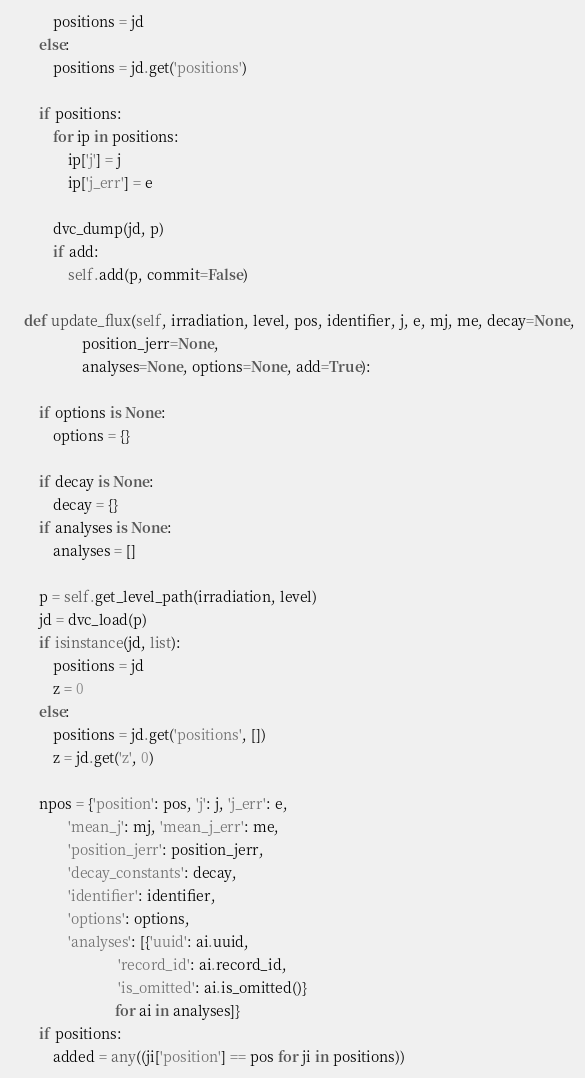Convert code to text. <code><loc_0><loc_0><loc_500><loc_500><_Python_>            positions = jd
        else:
            positions = jd.get('positions')

        if positions:
            for ip in positions:
                ip['j'] = j
                ip['j_err'] = e

            dvc_dump(jd, p)
            if add:
                self.add(p, commit=False)

    def update_flux(self, irradiation, level, pos, identifier, j, e, mj, me, decay=None,
                    position_jerr=None,
                    analyses=None, options=None, add=True):

        if options is None:
            options = {}

        if decay is None:
            decay = {}
        if analyses is None:
            analyses = []

        p = self.get_level_path(irradiation, level)
        jd = dvc_load(p)
        if isinstance(jd, list):
            positions = jd
            z = 0
        else:
            positions = jd.get('positions', [])
            z = jd.get('z', 0)

        npos = {'position': pos, 'j': j, 'j_err': e,
                'mean_j': mj, 'mean_j_err': me,
                'position_jerr': position_jerr,
                'decay_constants': decay,
                'identifier': identifier,
                'options': options,
                'analyses': [{'uuid': ai.uuid,
                              'record_id': ai.record_id,
                              'is_omitted': ai.is_omitted()}
                             for ai in analyses]}
        if positions:
            added = any((ji['position'] == pos for ji in positions))</code> 